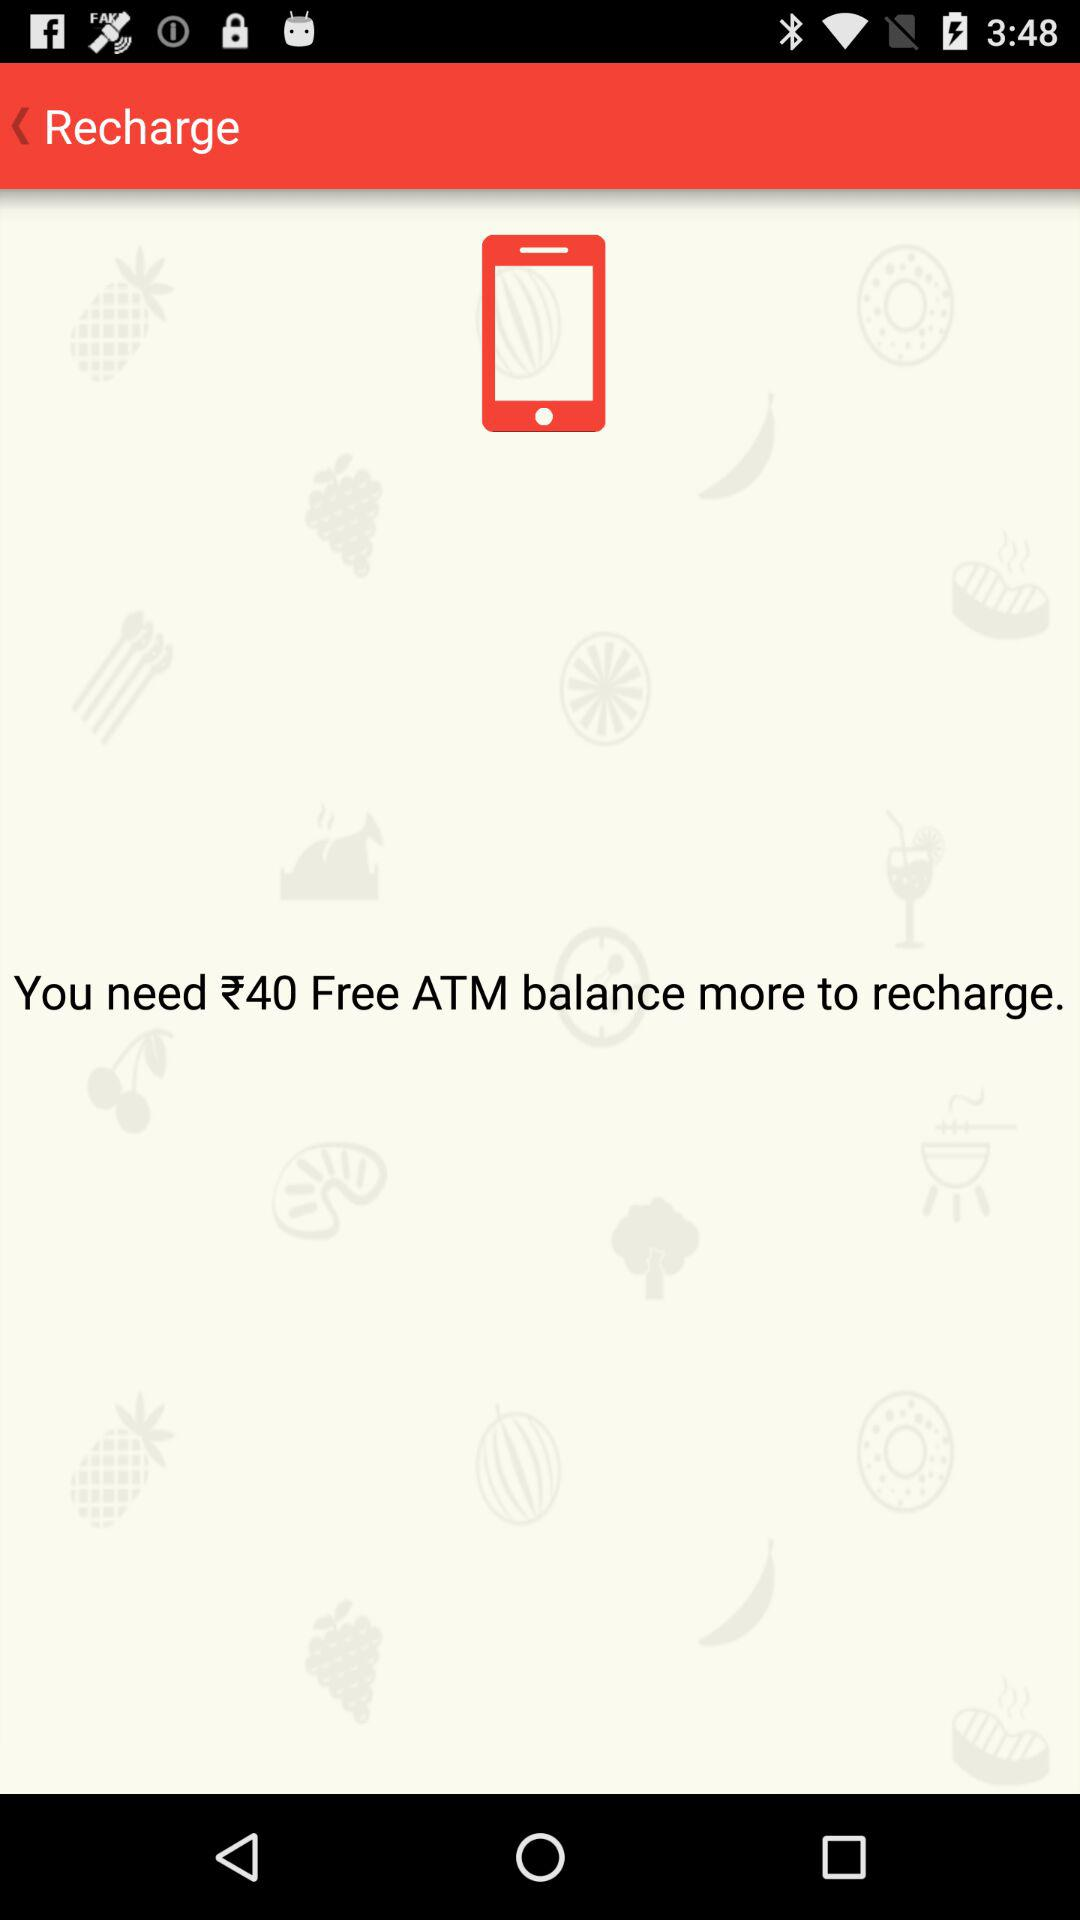How many more free ATM balances do I need to recharge?
Answer the question using a single word or phrase. 40 